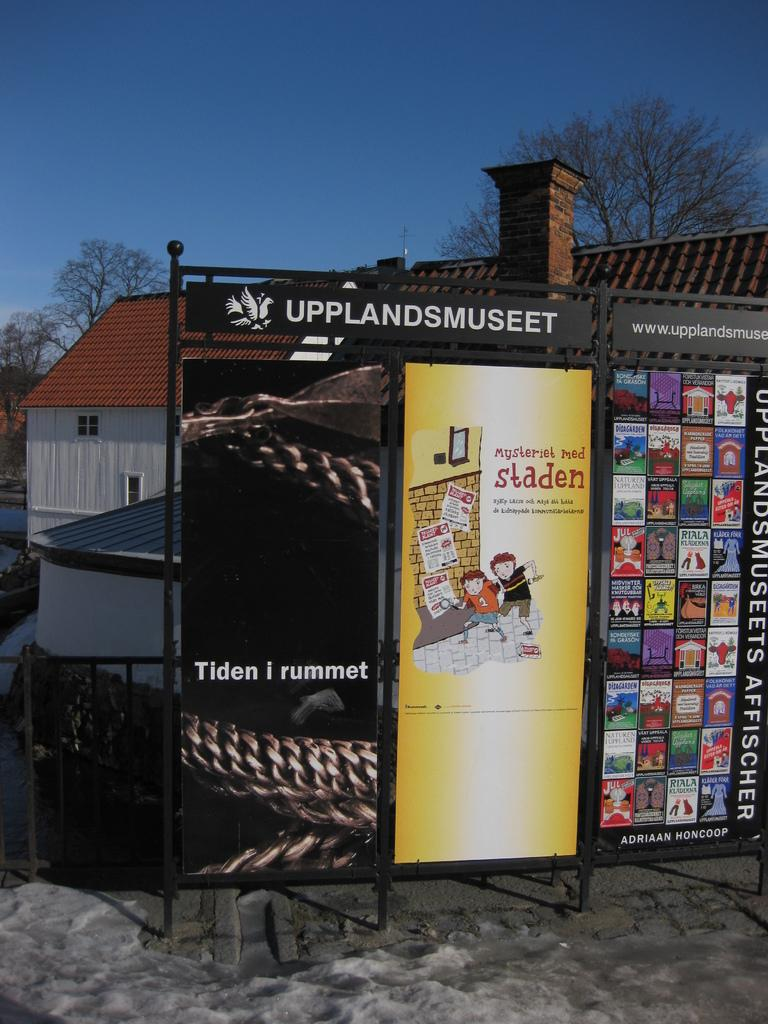<image>
Summarize the visual content of the image. A panel with outdoor advertisements in an area called Upplandsmuseet. 